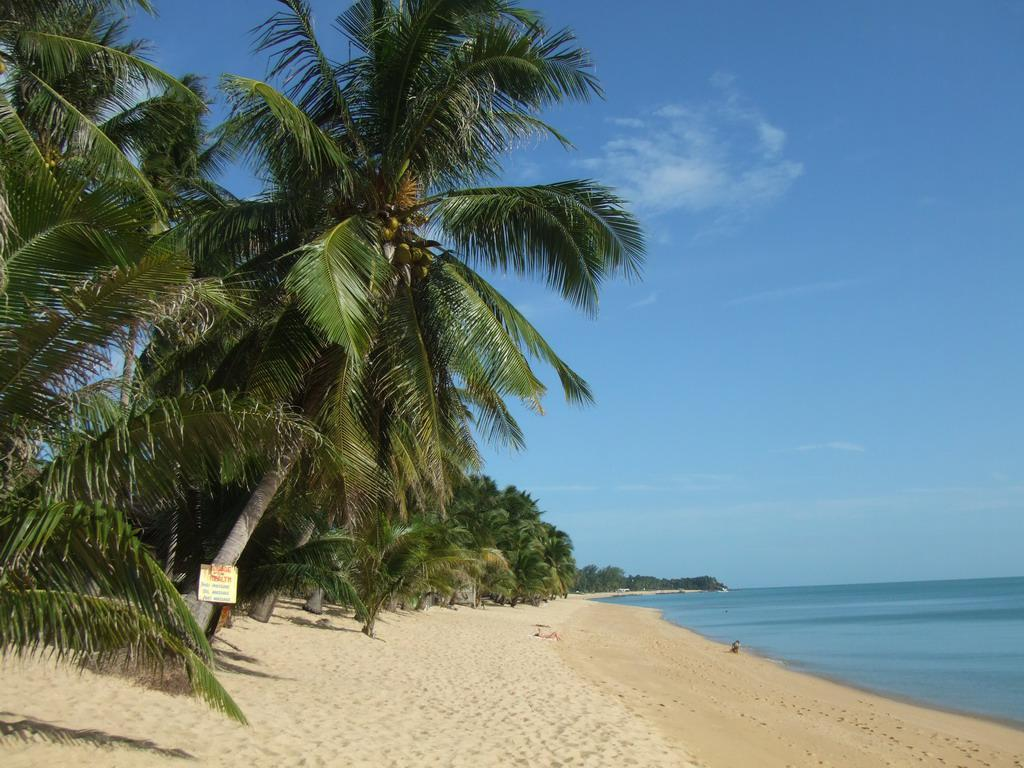What type of vegetation can be seen in the image? There are trees in the image. What is attached to one of the trees? There is a board attached to a tree. What type of terrain is present on the ground? There is sand on the ground. What can be seen on the right side of the image? There is water visible on the right side of the image. What is visible in the background of the image? The sky is visible in the image. What type of bubble can be seen floating in the water on the right side of the image? There is no bubble present in the image; it only features trees, a board, sand, water, and the sky. 